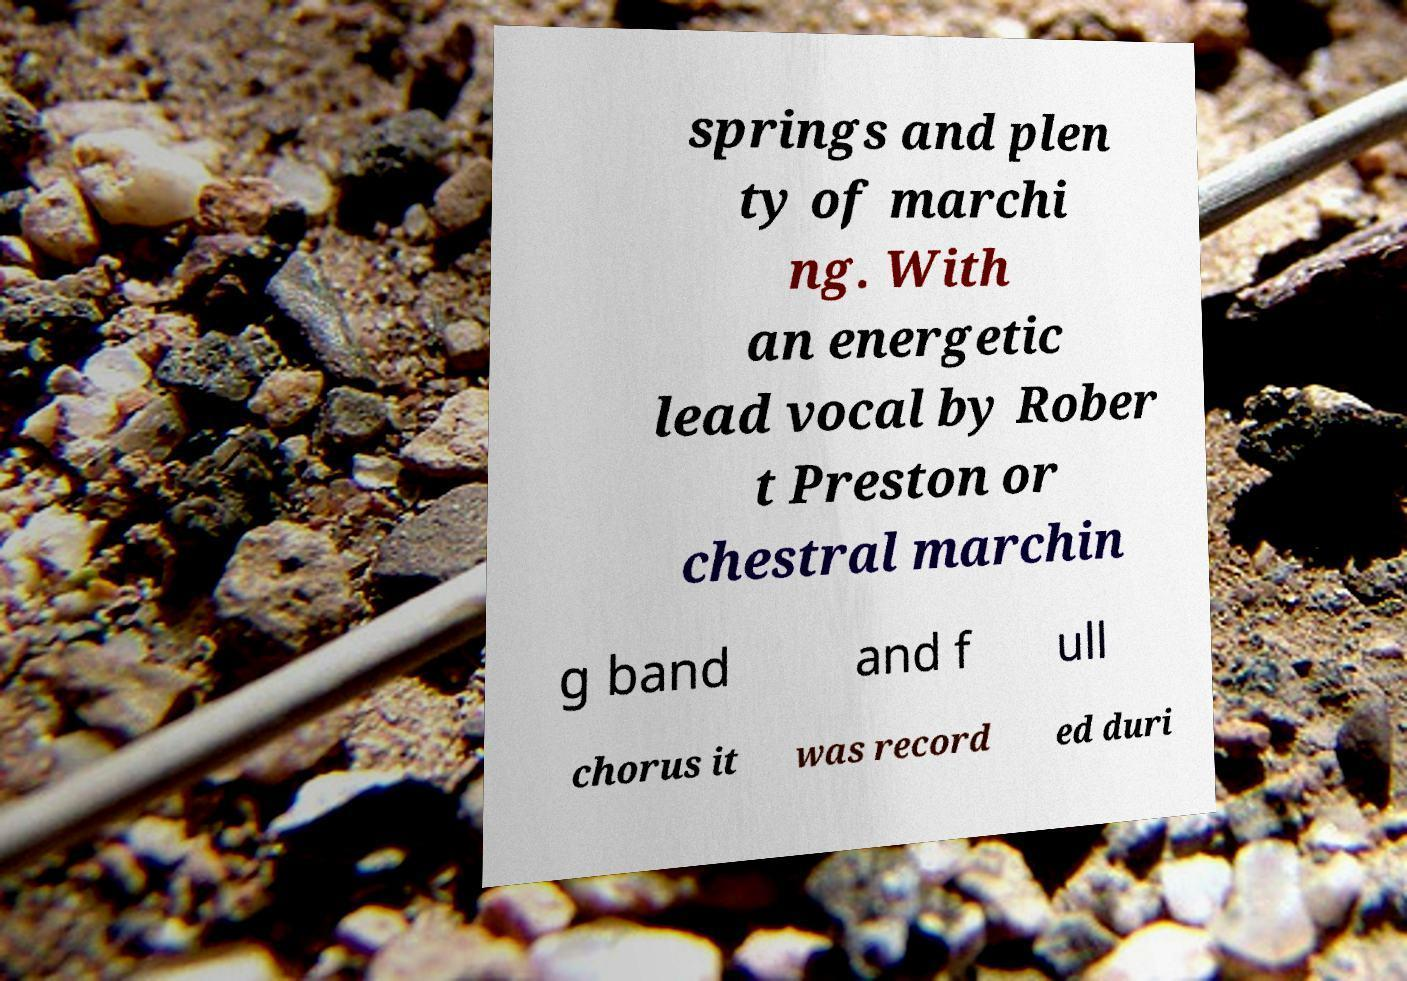I need the written content from this picture converted into text. Can you do that? springs and plen ty of marchi ng. With an energetic lead vocal by Rober t Preston or chestral marchin g band and f ull chorus it was record ed duri 